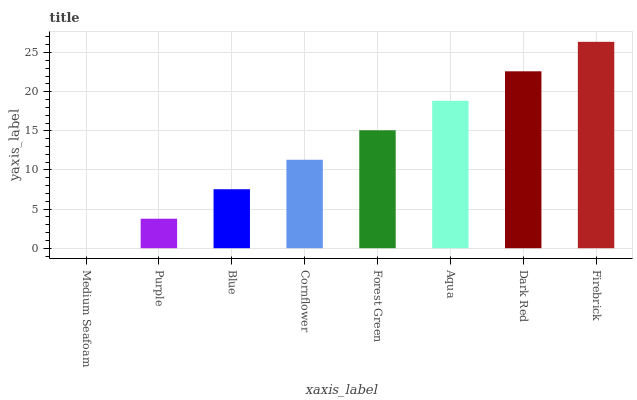Is Medium Seafoam the minimum?
Answer yes or no. Yes. Is Firebrick the maximum?
Answer yes or no. Yes. Is Purple the minimum?
Answer yes or no. No. Is Purple the maximum?
Answer yes or no. No. Is Purple greater than Medium Seafoam?
Answer yes or no. Yes. Is Medium Seafoam less than Purple?
Answer yes or no. Yes. Is Medium Seafoam greater than Purple?
Answer yes or no. No. Is Purple less than Medium Seafoam?
Answer yes or no. No. Is Forest Green the high median?
Answer yes or no. Yes. Is Cornflower the low median?
Answer yes or no. Yes. Is Aqua the high median?
Answer yes or no. No. Is Purple the low median?
Answer yes or no. No. 